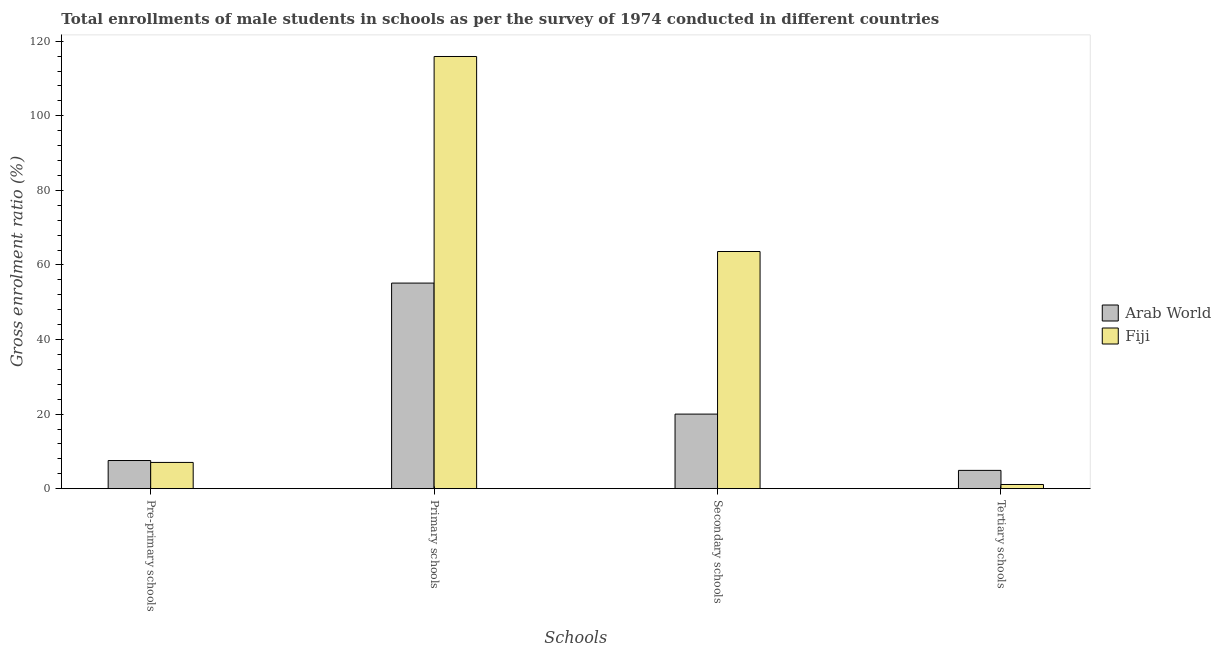How many different coloured bars are there?
Your answer should be very brief. 2. How many groups of bars are there?
Offer a terse response. 4. Are the number of bars on each tick of the X-axis equal?
Your response must be concise. Yes. How many bars are there on the 2nd tick from the left?
Offer a very short reply. 2. How many bars are there on the 2nd tick from the right?
Provide a succinct answer. 2. What is the label of the 3rd group of bars from the left?
Your answer should be compact. Secondary schools. What is the gross enrolment ratio(male) in primary schools in Arab World?
Give a very brief answer. 55.14. Across all countries, what is the maximum gross enrolment ratio(male) in secondary schools?
Make the answer very short. 63.6. Across all countries, what is the minimum gross enrolment ratio(male) in primary schools?
Your response must be concise. 55.14. In which country was the gross enrolment ratio(male) in pre-primary schools maximum?
Provide a succinct answer. Arab World. In which country was the gross enrolment ratio(male) in primary schools minimum?
Give a very brief answer. Arab World. What is the total gross enrolment ratio(male) in secondary schools in the graph?
Ensure brevity in your answer.  83.6. What is the difference between the gross enrolment ratio(male) in secondary schools in Fiji and that in Arab World?
Provide a succinct answer. 43.6. What is the difference between the gross enrolment ratio(male) in primary schools in Fiji and the gross enrolment ratio(male) in pre-primary schools in Arab World?
Provide a short and direct response. 108.35. What is the average gross enrolment ratio(male) in tertiary schools per country?
Your response must be concise. 3.01. What is the difference between the gross enrolment ratio(male) in tertiary schools and gross enrolment ratio(male) in secondary schools in Arab World?
Offer a very short reply. -15.09. What is the ratio of the gross enrolment ratio(male) in pre-primary schools in Fiji to that in Arab World?
Provide a succinct answer. 0.93. What is the difference between the highest and the second highest gross enrolment ratio(male) in pre-primary schools?
Ensure brevity in your answer.  0.51. What is the difference between the highest and the lowest gross enrolment ratio(male) in primary schools?
Your response must be concise. 60.77. In how many countries, is the gross enrolment ratio(male) in primary schools greater than the average gross enrolment ratio(male) in primary schools taken over all countries?
Ensure brevity in your answer.  1. What does the 2nd bar from the left in Tertiary schools represents?
Your response must be concise. Fiji. What does the 2nd bar from the right in Secondary schools represents?
Your response must be concise. Arab World. Is it the case that in every country, the sum of the gross enrolment ratio(male) in pre-primary schools and gross enrolment ratio(male) in primary schools is greater than the gross enrolment ratio(male) in secondary schools?
Your response must be concise. Yes. Are all the bars in the graph horizontal?
Offer a terse response. No. Are the values on the major ticks of Y-axis written in scientific E-notation?
Keep it short and to the point. No. How many legend labels are there?
Ensure brevity in your answer.  2. What is the title of the graph?
Your answer should be very brief. Total enrollments of male students in schools as per the survey of 1974 conducted in different countries. What is the label or title of the X-axis?
Keep it short and to the point. Schools. What is the label or title of the Y-axis?
Ensure brevity in your answer.  Gross enrolment ratio (%). What is the Gross enrolment ratio (%) of Arab World in Pre-primary schools?
Offer a terse response. 7.55. What is the Gross enrolment ratio (%) in Fiji in Pre-primary schools?
Your answer should be compact. 7.04. What is the Gross enrolment ratio (%) of Arab World in Primary schools?
Keep it short and to the point. 55.14. What is the Gross enrolment ratio (%) of Fiji in Primary schools?
Offer a very short reply. 115.9. What is the Gross enrolment ratio (%) in Arab World in Secondary schools?
Your response must be concise. 20. What is the Gross enrolment ratio (%) in Fiji in Secondary schools?
Offer a terse response. 63.6. What is the Gross enrolment ratio (%) in Arab World in Tertiary schools?
Provide a succinct answer. 4.91. What is the Gross enrolment ratio (%) of Fiji in Tertiary schools?
Your response must be concise. 1.12. Across all Schools, what is the maximum Gross enrolment ratio (%) in Arab World?
Provide a short and direct response. 55.14. Across all Schools, what is the maximum Gross enrolment ratio (%) in Fiji?
Your response must be concise. 115.9. Across all Schools, what is the minimum Gross enrolment ratio (%) in Arab World?
Provide a succinct answer. 4.91. Across all Schools, what is the minimum Gross enrolment ratio (%) of Fiji?
Your response must be concise. 1.12. What is the total Gross enrolment ratio (%) of Arab World in the graph?
Ensure brevity in your answer.  87.59. What is the total Gross enrolment ratio (%) of Fiji in the graph?
Your response must be concise. 187.67. What is the difference between the Gross enrolment ratio (%) in Arab World in Pre-primary schools and that in Primary schools?
Your response must be concise. -47.59. What is the difference between the Gross enrolment ratio (%) of Fiji in Pre-primary schools and that in Primary schools?
Your answer should be very brief. -108.86. What is the difference between the Gross enrolment ratio (%) in Arab World in Pre-primary schools and that in Secondary schools?
Offer a very short reply. -12.45. What is the difference between the Gross enrolment ratio (%) in Fiji in Pre-primary schools and that in Secondary schools?
Provide a succinct answer. -56.56. What is the difference between the Gross enrolment ratio (%) of Arab World in Pre-primary schools and that in Tertiary schools?
Keep it short and to the point. 2.64. What is the difference between the Gross enrolment ratio (%) in Fiji in Pre-primary schools and that in Tertiary schools?
Provide a short and direct response. 5.92. What is the difference between the Gross enrolment ratio (%) in Arab World in Primary schools and that in Secondary schools?
Give a very brief answer. 35.14. What is the difference between the Gross enrolment ratio (%) of Fiji in Primary schools and that in Secondary schools?
Your response must be concise. 52.3. What is the difference between the Gross enrolment ratio (%) of Arab World in Primary schools and that in Tertiary schools?
Keep it short and to the point. 50.23. What is the difference between the Gross enrolment ratio (%) of Fiji in Primary schools and that in Tertiary schools?
Make the answer very short. 114.78. What is the difference between the Gross enrolment ratio (%) of Arab World in Secondary schools and that in Tertiary schools?
Offer a terse response. 15.09. What is the difference between the Gross enrolment ratio (%) in Fiji in Secondary schools and that in Tertiary schools?
Provide a succinct answer. 62.48. What is the difference between the Gross enrolment ratio (%) in Arab World in Pre-primary schools and the Gross enrolment ratio (%) in Fiji in Primary schools?
Make the answer very short. -108.35. What is the difference between the Gross enrolment ratio (%) of Arab World in Pre-primary schools and the Gross enrolment ratio (%) of Fiji in Secondary schools?
Your answer should be compact. -56.05. What is the difference between the Gross enrolment ratio (%) of Arab World in Pre-primary schools and the Gross enrolment ratio (%) of Fiji in Tertiary schools?
Provide a succinct answer. 6.43. What is the difference between the Gross enrolment ratio (%) of Arab World in Primary schools and the Gross enrolment ratio (%) of Fiji in Secondary schools?
Your response must be concise. -8.47. What is the difference between the Gross enrolment ratio (%) in Arab World in Primary schools and the Gross enrolment ratio (%) in Fiji in Tertiary schools?
Your answer should be very brief. 54.01. What is the difference between the Gross enrolment ratio (%) of Arab World in Secondary schools and the Gross enrolment ratio (%) of Fiji in Tertiary schools?
Offer a terse response. 18.88. What is the average Gross enrolment ratio (%) in Arab World per Schools?
Your answer should be compact. 21.9. What is the average Gross enrolment ratio (%) in Fiji per Schools?
Your response must be concise. 46.92. What is the difference between the Gross enrolment ratio (%) of Arab World and Gross enrolment ratio (%) of Fiji in Pre-primary schools?
Give a very brief answer. 0.51. What is the difference between the Gross enrolment ratio (%) of Arab World and Gross enrolment ratio (%) of Fiji in Primary schools?
Keep it short and to the point. -60.77. What is the difference between the Gross enrolment ratio (%) in Arab World and Gross enrolment ratio (%) in Fiji in Secondary schools?
Ensure brevity in your answer.  -43.6. What is the difference between the Gross enrolment ratio (%) in Arab World and Gross enrolment ratio (%) in Fiji in Tertiary schools?
Your answer should be compact. 3.78. What is the ratio of the Gross enrolment ratio (%) in Arab World in Pre-primary schools to that in Primary schools?
Keep it short and to the point. 0.14. What is the ratio of the Gross enrolment ratio (%) in Fiji in Pre-primary schools to that in Primary schools?
Provide a short and direct response. 0.06. What is the ratio of the Gross enrolment ratio (%) of Arab World in Pre-primary schools to that in Secondary schools?
Give a very brief answer. 0.38. What is the ratio of the Gross enrolment ratio (%) of Fiji in Pre-primary schools to that in Secondary schools?
Keep it short and to the point. 0.11. What is the ratio of the Gross enrolment ratio (%) of Arab World in Pre-primary schools to that in Tertiary schools?
Provide a succinct answer. 1.54. What is the ratio of the Gross enrolment ratio (%) in Fiji in Pre-primary schools to that in Tertiary schools?
Your answer should be compact. 6.27. What is the ratio of the Gross enrolment ratio (%) of Arab World in Primary schools to that in Secondary schools?
Ensure brevity in your answer.  2.76. What is the ratio of the Gross enrolment ratio (%) of Fiji in Primary schools to that in Secondary schools?
Make the answer very short. 1.82. What is the ratio of the Gross enrolment ratio (%) in Arab World in Primary schools to that in Tertiary schools?
Offer a very short reply. 11.24. What is the ratio of the Gross enrolment ratio (%) in Fiji in Primary schools to that in Tertiary schools?
Keep it short and to the point. 103.28. What is the ratio of the Gross enrolment ratio (%) of Arab World in Secondary schools to that in Tertiary schools?
Ensure brevity in your answer.  4.08. What is the ratio of the Gross enrolment ratio (%) of Fiji in Secondary schools to that in Tertiary schools?
Provide a succinct answer. 56.67. What is the difference between the highest and the second highest Gross enrolment ratio (%) of Arab World?
Give a very brief answer. 35.14. What is the difference between the highest and the second highest Gross enrolment ratio (%) in Fiji?
Make the answer very short. 52.3. What is the difference between the highest and the lowest Gross enrolment ratio (%) in Arab World?
Keep it short and to the point. 50.23. What is the difference between the highest and the lowest Gross enrolment ratio (%) in Fiji?
Offer a very short reply. 114.78. 